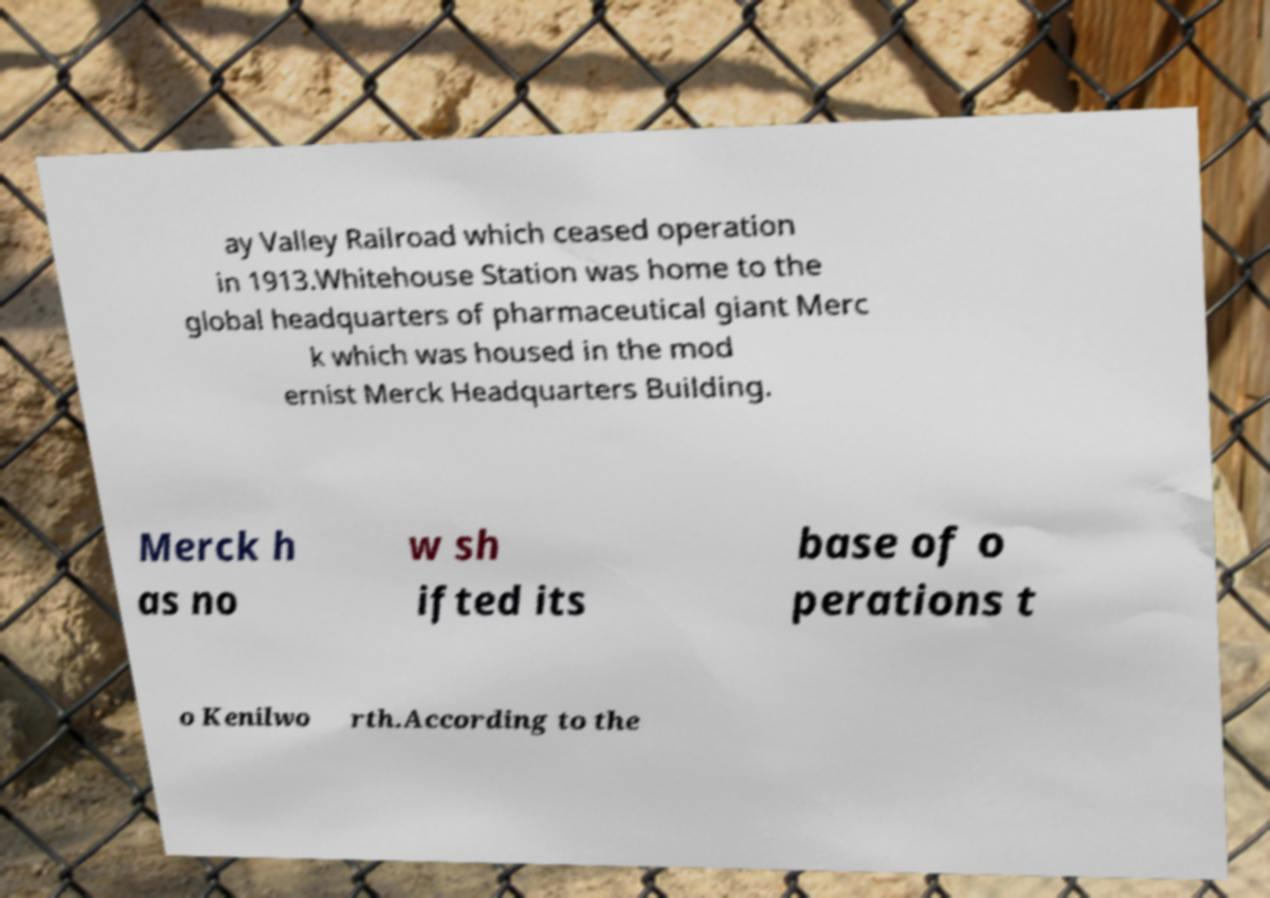Could you assist in decoding the text presented in this image and type it out clearly? ay Valley Railroad which ceased operation in 1913.Whitehouse Station was home to the global headquarters of pharmaceutical giant Merc k which was housed in the mod ernist Merck Headquarters Building. Merck h as no w sh ifted its base of o perations t o Kenilwo rth.According to the 